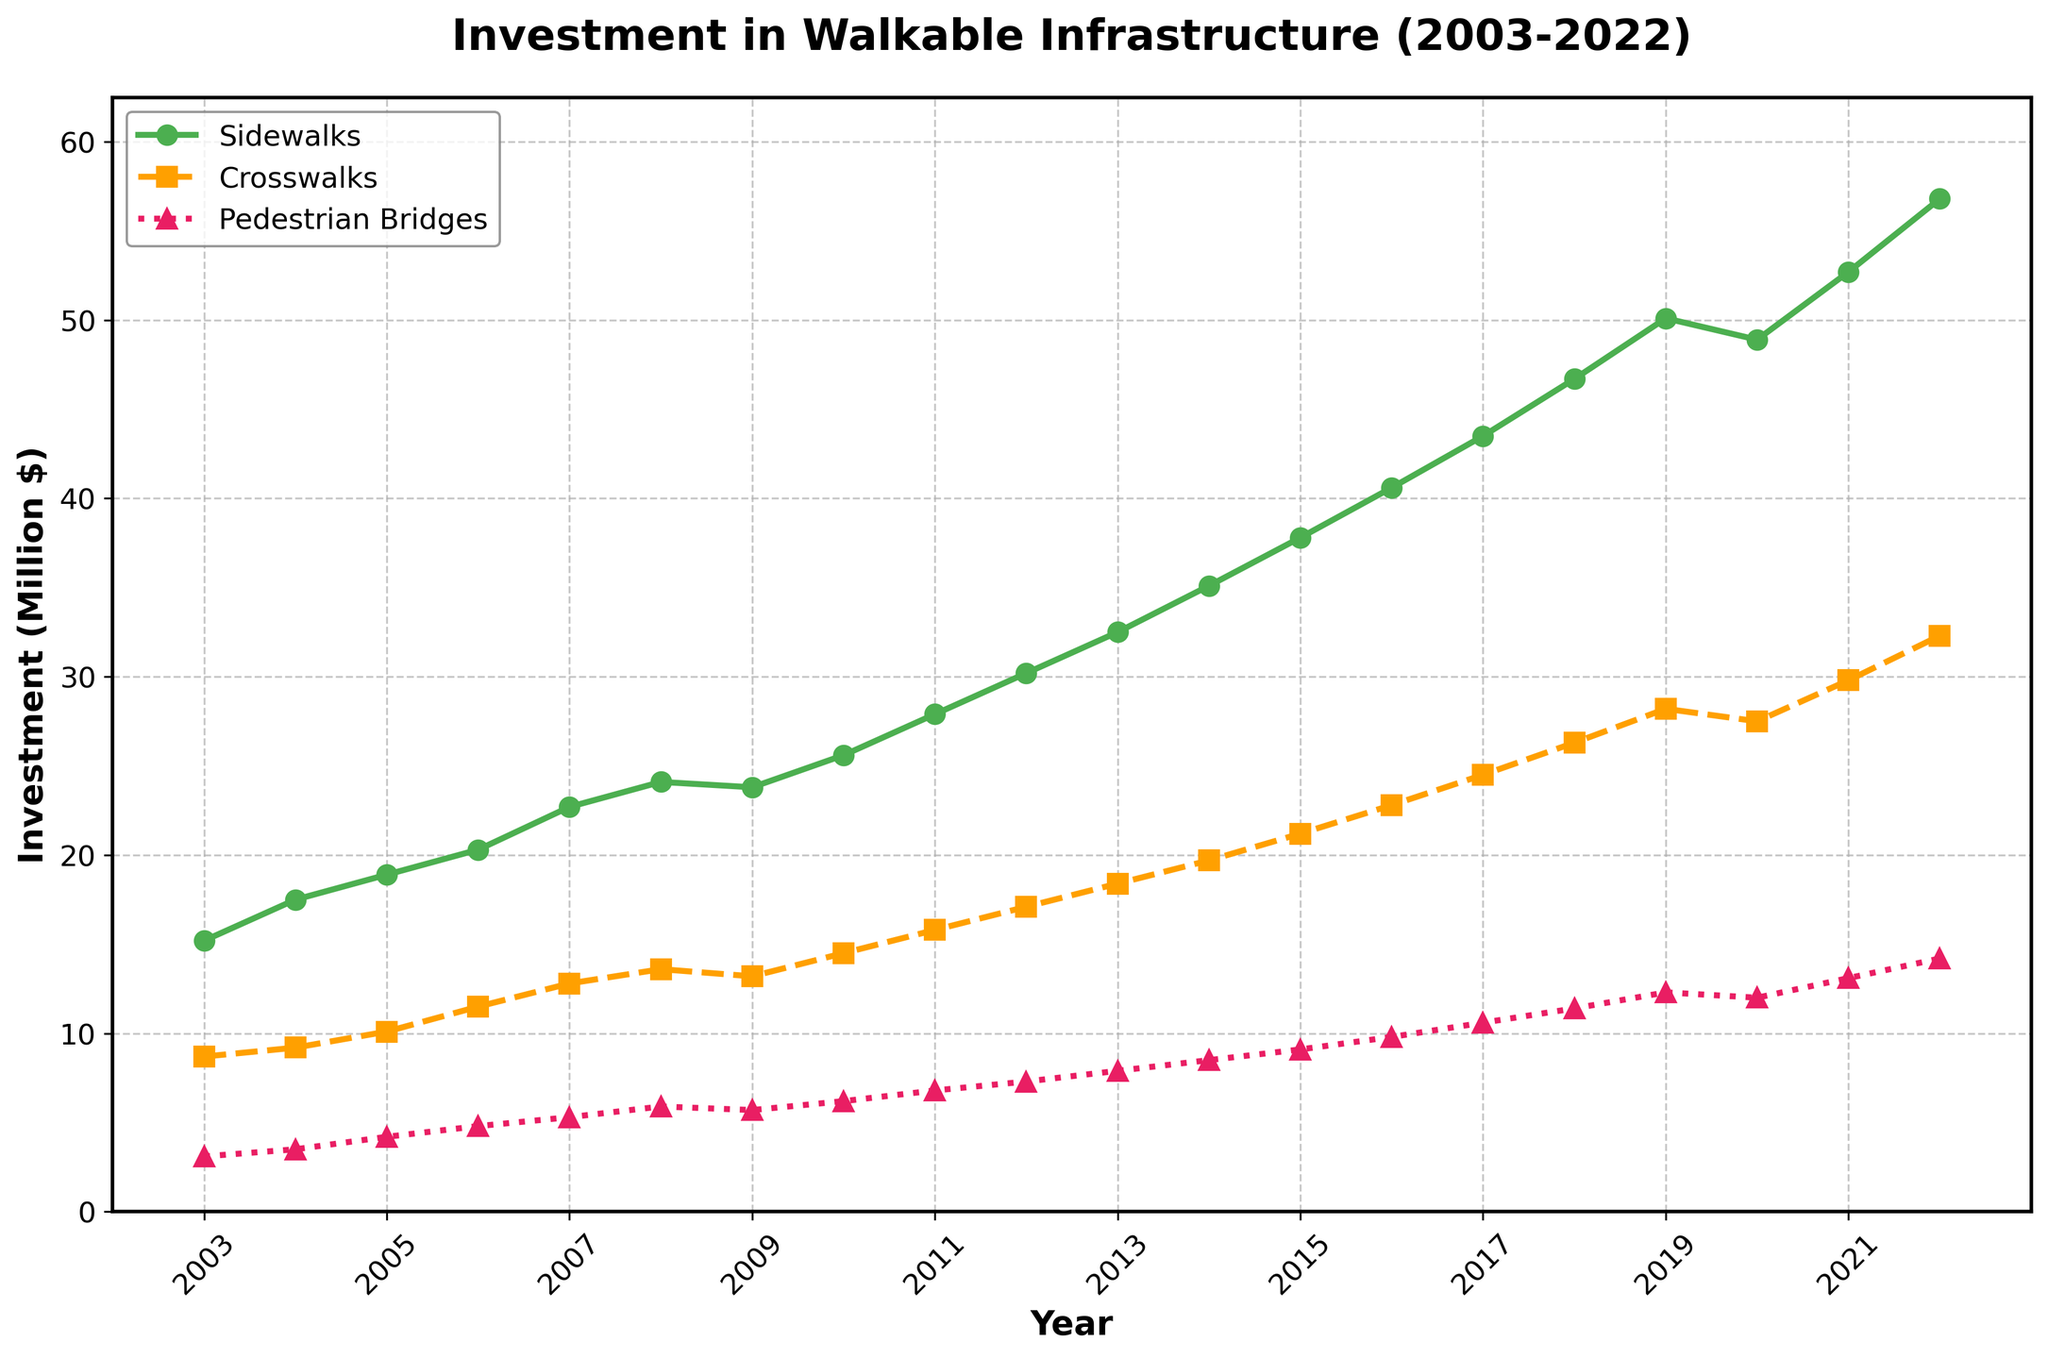What is the total investment in walkable infrastructure in 2022? To find the total investment in walkable infrastructure in 2022, sum the investments in sidewalks, crosswalks, and pedestrian bridges for that year: 56.8 + 32.3 + 14.2 = 103.3 million dollars
Answer: 103.3 million dollars Which project type saw the highest investment in 2020? The highest investment in 2020 can be identified by comparing the values for sidewalks, crosswalks, and pedestrian bridges. The values are 48.9, 27.5, and 12.0 million dollars, respectively. Sidewalks have the highest value.
Answer: Sidewalks How did the investment in crosswalks change from 2003 to 2022? To determine the change, subtract the investment in crosswalks in 2003 from that in 2022: 32.3 - 8.7 = 23.6 million dollars increase
Answer: 23.6 million dollars In which year did pedestrian bridges receive their highest investment? The highest investment in pedestrian bridges is found by locating the peak value in the series for pedestrian bridges. The highest investment is 14.2 million dollars in 2022.
Answer: 2022 Compare the average investments in sidewalks and crosswalks over the 20-year period. Which is higher? Calculate the average investment for each by summing their respective yearly investments and dividing by the number of years:
Sidewalks: (15.2 + 17.5 + 18.9 + 20.3 + 22.7 + 24.1 + 23.8 + 25.6 + 27.9 + 30.2 + 32.5 + 35.1 + 37.8 + 40.6 + 43.5 + 46.7 + 50.1 + 48.9 + 52.7 + 56.8)/20 = 32.9 million dollars
Crosswalks: (8.7 + 9.2 + 10.1 + 11.5 + 12.8 + 13.6 + 13.2 + 14.5 + 15.8 + 17.1 + 18.4 + 19.7 + 21.2 + 22.8 + 24.5 + 26.3 + 28.2 + 27.5 + 29.8 + 32.3)/20 = 18.3 million dollars
Comparing the averages, sidewalks have a higher investment.
Answer: Sidewalks What was the trend in investment in pedestrian bridges from 2018 to 2022? To identify the trend, review the values for pedestrian bridges from 2018 to 2022: 11.4, 12.3, 12.0, 13.1, 14.2. The investment increased from 11.4 to 14.2 million dollars, indicating an upward trend.
Answer: Upward Did the investment in crosswalks ever decrease from one year to the next? If so, when? Check for any year where the investment in crosswalks decreases compared to the previous year. The investment decreased from 2019 (28.2 million dollars) to 2020 (27.5 million dollars).
Answer: Yes, from 2019 to 2020 Compare the investments in sidewalks and pedestrian bridges in 2015. How much more was invested in sidewalks? Subtract the investment in pedestrian bridges from the investment in sidewalks in 2015: 37.8 - 9.1 = 28.7 million dollars more was invested in sidewalks.
Answer: 28.7 million dollars Which project type had the most steady increase in investment over the years? Reviewing the lines in the figure, sidewalks show a consistent yearly increase with minor fluctuations compared to crosswalks and pedestrian bridges, which experienced slight declines at certain years.
Answer: Sidewalks 